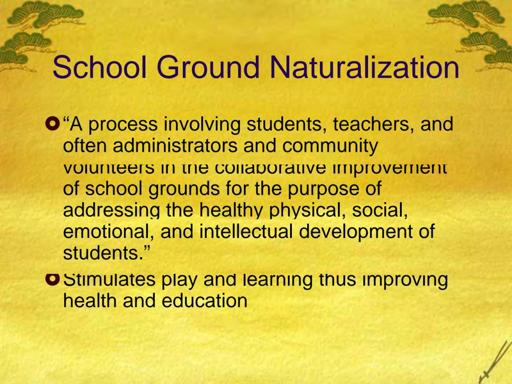What are some benefits of school ground naturalization? The benefits of school ground naturalization are extensive and impactful. By transforming school landscapes into more natural settings, students gain access to dynamic and stimulating environments that encourage physical activity and play. This can significantly improve physical health and reduce stress levels. Socially, these naturalized grounds foster stronger interactions among students and a sense of community. Academically, hands-on learning through environments enriched with native plants and wildlife serves as a living classroom, enhancing educational outcomes and nurturing a connection with nature. 